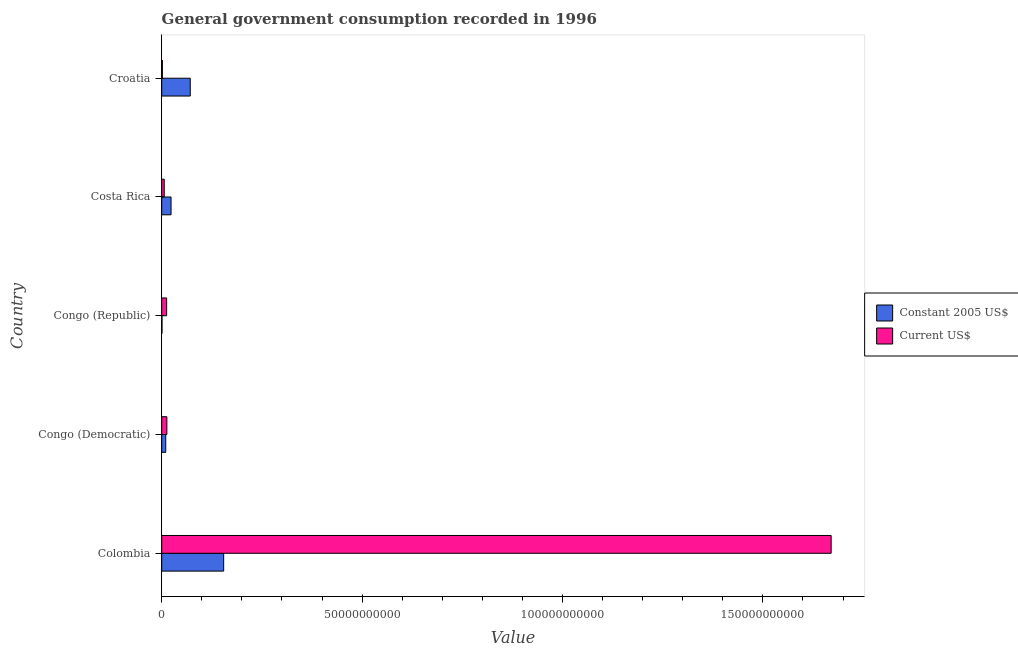How many different coloured bars are there?
Your answer should be very brief. 2. Are the number of bars per tick equal to the number of legend labels?
Your response must be concise. Yes. Are the number of bars on each tick of the Y-axis equal?
Your answer should be compact. Yes. How many bars are there on the 2nd tick from the top?
Offer a very short reply. 2. How many bars are there on the 3rd tick from the bottom?
Give a very brief answer. 2. In how many cases, is the number of bars for a given country not equal to the number of legend labels?
Provide a succinct answer. 0. What is the value consumed in constant 2005 us$ in Croatia?
Ensure brevity in your answer.  7.12e+09. Across all countries, what is the maximum value consumed in current us$?
Provide a succinct answer. 1.67e+11. Across all countries, what is the minimum value consumed in current us$?
Offer a very short reply. 1.74e+08. In which country was the value consumed in constant 2005 us$ minimum?
Keep it short and to the point. Congo (Republic). What is the total value consumed in constant 2005 us$ in the graph?
Provide a short and direct response. 2.60e+1. What is the difference between the value consumed in constant 2005 us$ in Colombia and that in Croatia?
Your answer should be very brief. 8.34e+09. What is the difference between the value consumed in current us$ in Costa Rica and the value consumed in constant 2005 us$ in Colombia?
Your response must be concise. -1.48e+1. What is the average value consumed in constant 2005 us$ per country?
Make the answer very short. 5.20e+09. What is the difference between the value consumed in current us$ and value consumed in constant 2005 us$ in Congo (Democratic)?
Keep it short and to the point. 2.81e+08. What is the ratio of the value consumed in constant 2005 us$ in Colombia to that in Congo (Republic)?
Provide a succinct answer. 210.34. What is the difference between the highest and the second highest value consumed in current us$?
Provide a succinct answer. 1.66e+11. What is the difference between the highest and the lowest value consumed in constant 2005 us$?
Your answer should be very brief. 1.54e+1. What does the 1st bar from the top in Colombia represents?
Ensure brevity in your answer.  Current US$. What does the 1st bar from the bottom in Croatia represents?
Your answer should be very brief. Constant 2005 US$. How many bars are there?
Give a very brief answer. 10. Are the values on the major ticks of X-axis written in scientific E-notation?
Make the answer very short. No. Does the graph contain any zero values?
Provide a succinct answer. No. Where does the legend appear in the graph?
Offer a terse response. Center right. How are the legend labels stacked?
Keep it short and to the point. Vertical. What is the title of the graph?
Your response must be concise. General government consumption recorded in 1996. Does "Secondary school" appear as one of the legend labels in the graph?
Your answer should be very brief. No. What is the label or title of the X-axis?
Give a very brief answer. Value. What is the Value of Constant 2005 US$ in Colombia?
Offer a very short reply. 1.55e+1. What is the Value of Current US$ in Colombia?
Your response must be concise. 1.67e+11. What is the Value in Constant 2005 US$ in Congo (Democratic)?
Your response must be concise. 1.01e+09. What is the Value in Current US$ in Congo (Democratic)?
Your answer should be very brief. 1.29e+09. What is the Value in Constant 2005 US$ in Congo (Republic)?
Give a very brief answer. 7.35e+07. What is the Value in Current US$ in Congo (Republic)?
Offer a terse response. 1.23e+09. What is the Value in Constant 2005 US$ in Costa Rica?
Provide a short and direct response. 2.33e+09. What is the Value of Current US$ in Costa Rica?
Provide a short and direct response. 6.31e+08. What is the Value in Constant 2005 US$ in Croatia?
Ensure brevity in your answer.  7.12e+09. What is the Value in Current US$ in Croatia?
Provide a succinct answer. 1.74e+08. Across all countries, what is the maximum Value of Constant 2005 US$?
Your response must be concise. 1.55e+1. Across all countries, what is the maximum Value of Current US$?
Make the answer very short. 1.67e+11. Across all countries, what is the minimum Value of Constant 2005 US$?
Provide a short and direct response. 7.35e+07. Across all countries, what is the minimum Value in Current US$?
Keep it short and to the point. 1.74e+08. What is the total Value of Constant 2005 US$ in the graph?
Your answer should be compact. 2.60e+1. What is the total Value of Current US$ in the graph?
Give a very brief answer. 1.70e+11. What is the difference between the Value in Constant 2005 US$ in Colombia and that in Congo (Democratic)?
Offer a very short reply. 1.45e+1. What is the difference between the Value in Current US$ in Colombia and that in Congo (Democratic)?
Make the answer very short. 1.66e+11. What is the difference between the Value of Constant 2005 US$ in Colombia and that in Congo (Republic)?
Make the answer very short. 1.54e+1. What is the difference between the Value in Current US$ in Colombia and that in Congo (Republic)?
Your answer should be compact. 1.66e+11. What is the difference between the Value in Constant 2005 US$ in Colombia and that in Costa Rica?
Give a very brief answer. 1.31e+1. What is the difference between the Value of Current US$ in Colombia and that in Costa Rica?
Your response must be concise. 1.66e+11. What is the difference between the Value in Constant 2005 US$ in Colombia and that in Croatia?
Keep it short and to the point. 8.34e+09. What is the difference between the Value of Current US$ in Colombia and that in Croatia?
Provide a succinct answer. 1.67e+11. What is the difference between the Value in Constant 2005 US$ in Congo (Democratic) and that in Congo (Republic)?
Make the answer very short. 9.36e+08. What is the difference between the Value of Current US$ in Congo (Democratic) and that in Congo (Republic)?
Provide a succinct answer. 5.99e+07. What is the difference between the Value of Constant 2005 US$ in Congo (Democratic) and that in Costa Rica?
Your answer should be very brief. -1.32e+09. What is the difference between the Value in Current US$ in Congo (Democratic) and that in Costa Rica?
Keep it short and to the point. 6.59e+08. What is the difference between the Value in Constant 2005 US$ in Congo (Democratic) and that in Croatia?
Your response must be concise. -6.11e+09. What is the difference between the Value of Current US$ in Congo (Democratic) and that in Croatia?
Provide a succinct answer. 1.12e+09. What is the difference between the Value in Constant 2005 US$ in Congo (Republic) and that in Costa Rica?
Provide a short and direct response. -2.25e+09. What is the difference between the Value of Current US$ in Congo (Republic) and that in Costa Rica?
Offer a very short reply. 5.99e+08. What is the difference between the Value of Constant 2005 US$ in Congo (Republic) and that in Croatia?
Make the answer very short. -7.05e+09. What is the difference between the Value of Current US$ in Congo (Republic) and that in Croatia?
Keep it short and to the point. 1.06e+09. What is the difference between the Value in Constant 2005 US$ in Costa Rica and that in Croatia?
Offer a very short reply. -4.79e+09. What is the difference between the Value of Current US$ in Costa Rica and that in Croatia?
Offer a terse response. 4.57e+08. What is the difference between the Value of Constant 2005 US$ in Colombia and the Value of Current US$ in Congo (Democratic)?
Keep it short and to the point. 1.42e+1. What is the difference between the Value in Constant 2005 US$ in Colombia and the Value in Current US$ in Congo (Republic)?
Offer a very short reply. 1.42e+1. What is the difference between the Value of Constant 2005 US$ in Colombia and the Value of Current US$ in Costa Rica?
Provide a succinct answer. 1.48e+1. What is the difference between the Value in Constant 2005 US$ in Colombia and the Value in Current US$ in Croatia?
Offer a terse response. 1.53e+1. What is the difference between the Value of Constant 2005 US$ in Congo (Democratic) and the Value of Current US$ in Congo (Republic)?
Keep it short and to the point. -2.21e+08. What is the difference between the Value in Constant 2005 US$ in Congo (Democratic) and the Value in Current US$ in Costa Rica?
Provide a short and direct response. 3.79e+08. What is the difference between the Value of Constant 2005 US$ in Congo (Democratic) and the Value of Current US$ in Croatia?
Keep it short and to the point. 8.36e+08. What is the difference between the Value of Constant 2005 US$ in Congo (Republic) and the Value of Current US$ in Costa Rica?
Offer a very short reply. -5.57e+08. What is the difference between the Value in Constant 2005 US$ in Congo (Republic) and the Value in Current US$ in Croatia?
Your answer should be compact. -1.00e+08. What is the difference between the Value of Constant 2005 US$ in Costa Rica and the Value of Current US$ in Croatia?
Ensure brevity in your answer.  2.15e+09. What is the average Value in Constant 2005 US$ per country?
Your answer should be very brief. 5.20e+09. What is the average Value of Current US$ per country?
Offer a terse response. 3.41e+1. What is the difference between the Value in Constant 2005 US$ and Value in Current US$ in Colombia?
Provide a succinct answer. -1.52e+11. What is the difference between the Value in Constant 2005 US$ and Value in Current US$ in Congo (Democratic)?
Your answer should be compact. -2.81e+08. What is the difference between the Value of Constant 2005 US$ and Value of Current US$ in Congo (Republic)?
Your answer should be very brief. -1.16e+09. What is the difference between the Value of Constant 2005 US$ and Value of Current US$ in Costa Rica?
Make the answer very short. 1.70e+09. What is the difference between the Value of Constant 2005 US$ and Value of Current US$ in Croatia?
Your response must be concise. 6.95e+09. What is the ratio of the Value in Constant 2005 US$ in Colombia to that in Congo (Democratic)?
Make the answer very short. 15.31. What is the ratio of the Value in Current US$ in Colombia to that in Congo (Democratic)?
Offer a very short reply. 129.48. What is the ratio of the Value in Constant 2005 US$ in Colombia to that in Congo (Republic)?
Provide a succinct answer. 210.34. What is the ratio of the Value of Current US$ in Colombia to that in Congo (Republic)?
Make the answer very short. 135.78. What is the ratio of the Value of Constant 2005 US$ in Colombia to that in Costa Rica?
Offer a very short reply. 6.64. What is the ratio of the Value of Current US$ in Colombia to that in Costa Rica?
Provide a short and direct response. 264.78. What is the ratio of the Value in Constant 2005 US$ in Colombia to that in Croatia?
Offer a terse response. 2.17. What is the ratio of the Value in Current US$ in Colombia to that in Croatia?
Provide a short and direct response. 961.41. What is the ratio of the Value in Constant 2005 US$ in Congo (Democratic) to that in Congo (Republic)?
Provide a succinct answer. 13.73. What is the ratio of the Value in Current US$ in Congo (Democratic) to that in Congo (Republic)?
Make the answer very short. 1.05. What is the ratio of the Value in Constant 2005 US$ in Congo (Democratic) to that in Costa Rica?
Make the answer very short. 0.43. What is the ratio of the Value in Current US$ in Congo (Democratic) to that in Costa Rica?
Keep it short and to the point. 2.04. What is the ratio of the Value of Constant 2005 US$ in Congo (Democratic) to that in Croatia?
Ensure brevity in your answer.  0.14. What is the ratio of the Value of Current US$ in Congo (Democratic) to that in Croatia?
Your response must be concise. 7.43. What is the ratio of the Value in Constant 2005 US$ in Congo (Republic) to that in Costa Rica?
Provide a short and direct response. 0.03. What is the ratio of the Value of Current US$ in Congo (Republic) to that in Costa Rica?
Keep it short and to the point. 1.95. What is the ratio of the Value of Constant 2005 US$ in Congo (Republic) to that in Croatia?
Your answer should be very brief. 0.01. What is the ratio of the Value of Current US$ in Congo (Republic) to that in Croatia?
Offer a terse response. 7.08. What is the ratio of the Value of Constant 2005 US$ in Costa Rica to that in Croatia?
Your answer should be very brief. 0.33. What is the ratio of the Value of Current US$ in Costa Rica to that in Croatia?
Your answer should be very brief. 3.63. What is the difference between the highest and the second highest Value in Constant 2005 US$?
Provide a short and direct response. 8.34e+09. What is the difference between the highest and the second highest Value in Current US$?
Your answer should be very brief. 1.66e+11. What is the difference between the highest and the lowest Value in Constant 2005 US$?
Offer a terse response. 1.54e+1. What is the difference between the highest and the lowest Value of Current US$?
Keep it short and to the point. 1.67e+11. 